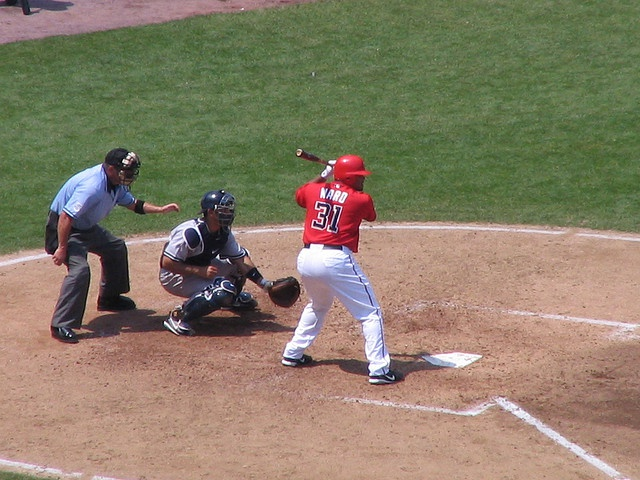Describe the objects in this image and their specific colors. I can see people in gray, lavender, darkgray, and tan tones, people in gray, black, and maroon tones, people in gray, black, and maroon tones, baseball glove in gray, black, maroon, and brown tones, and baseball bat in gray, maroon, and black tones in this image. 